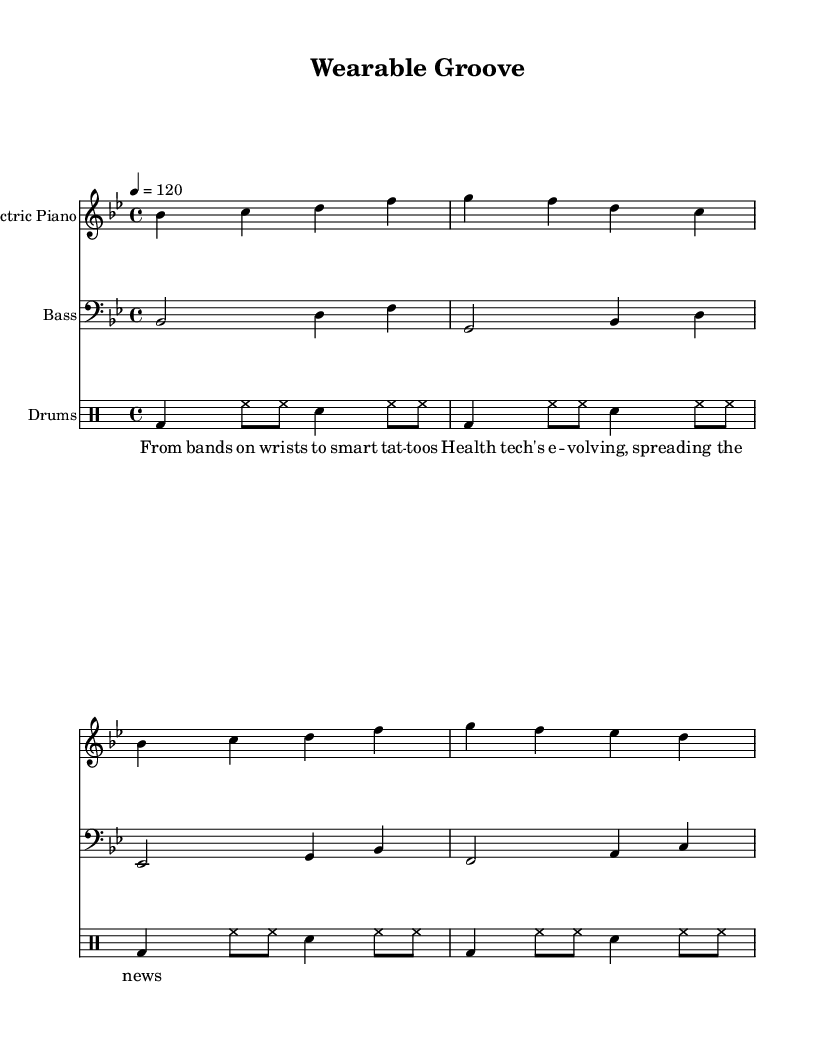What is the key signature of this music? The key signature listed in the global section shows "bes", which indicates that this piece is in B-flat major, containing two flats (B-flat and E-flat).
Answer: B-flat major What is the time signature present in the sheet music? The time signature indicated in the global section is "4/4", which means there are four beats in each measure and the quarter note receives one beat.
Answer: 4/4 What is the tempo of the music? The tempo is specified as "4 = 120", indicating that there are 120 quarter note beats per minute, which characterizes the song's pace.
Answer: 120 How many instruments are used in this piece? The score includes a total of three distinct parts: electric piano, bass guitar, and drums, which provide a full ensemble sound.
Answer: Three What is the primary theme of the lyrics? The lyrics discuss the evolution of health technology, particularly wearable devices, which reflects the ongoing advancements in personal health monitoring.
Answer: Wearable health technology Which musical form is most common in Disco music exemplified here? The Disco genre often features repetitive and danceable rhythms with a catchy melody, evident in the structured sections of the electric piano, bass, and drums used in this piece.
Answer: Repetitive rhythmic structure 